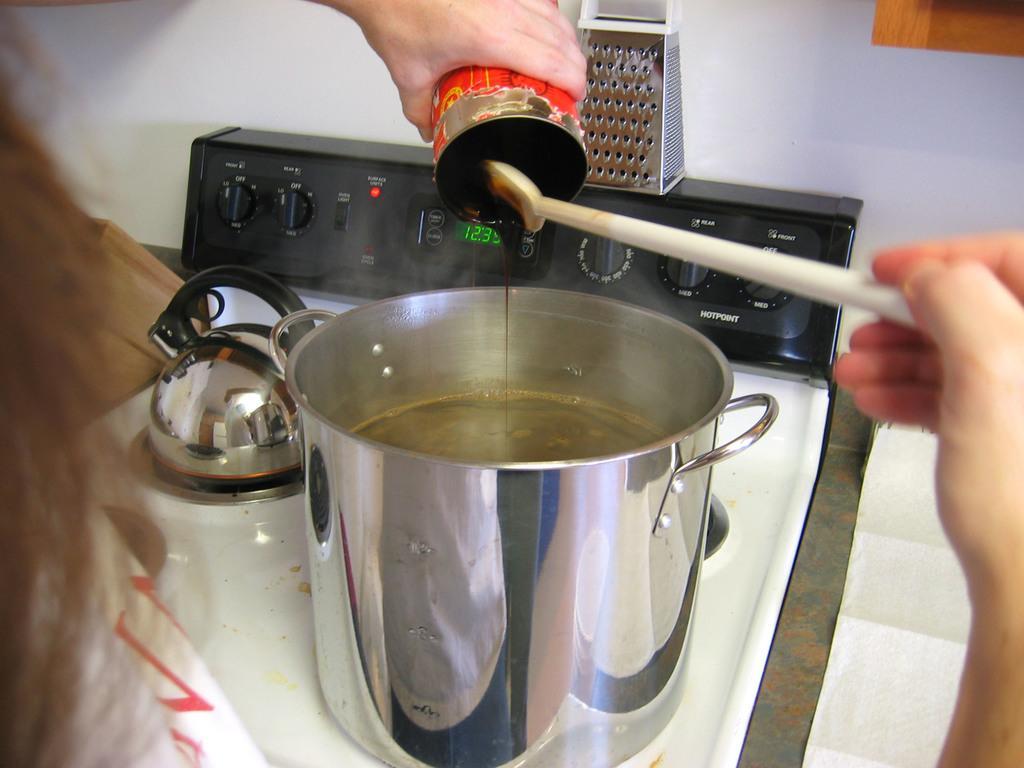How would you summarize this image in a sentence or two? In this image I can see a person is holding a bottle and spoon in the hands and pouring some liquid into a vessel which is placed on a table. At the back of this vessel I can see a black color machine. On the top of the image I can see a wall. 